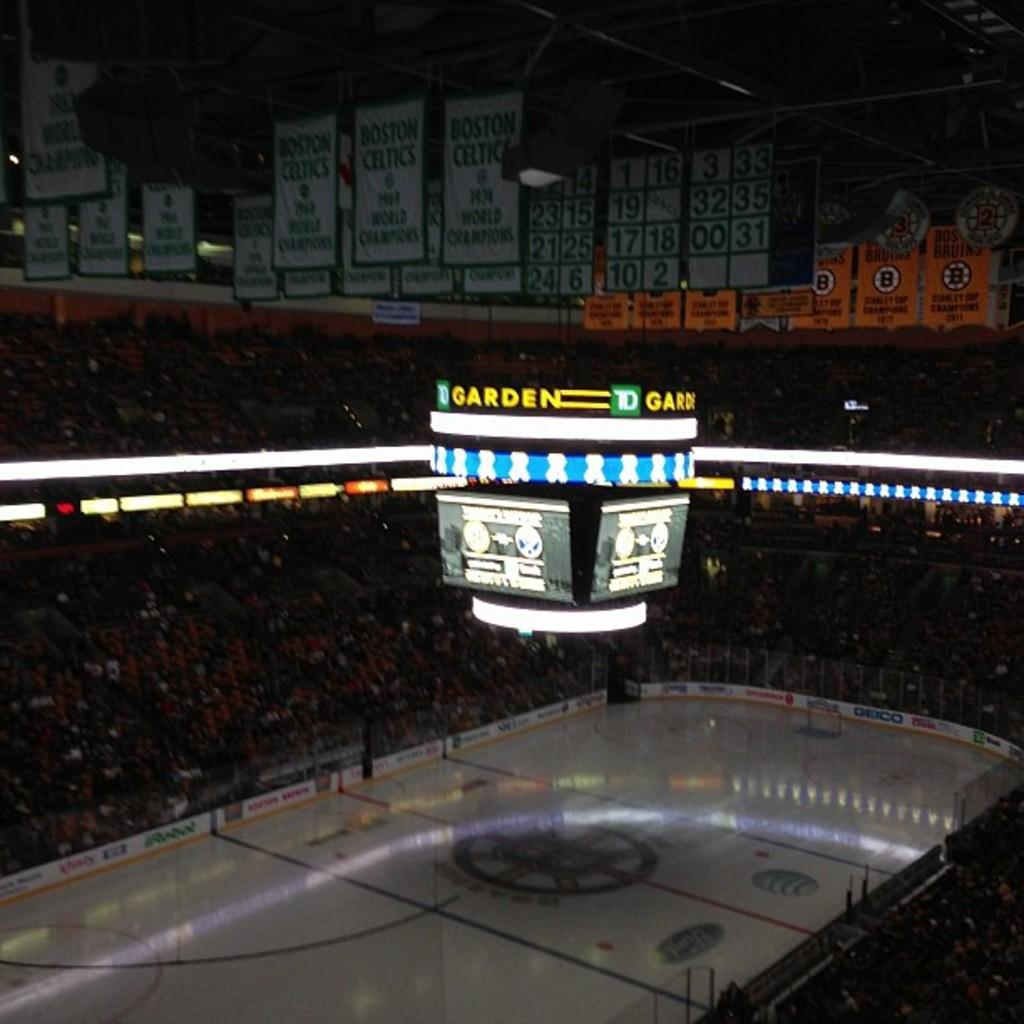What type of location is depicted in the image? The image appears to be a stadium. What electronic devices are present in the image? There are screens in the image. What can be seen illuminating the area in the image? There are lights in the image. What type of signage is visible in the image? There are boards with text in the image. How many people are present in the image? There are many people in the image. Are the people in the image fighting with each other? There is no indication of a fight or any conflict in the image; it simply shows a stadium with many people present. 